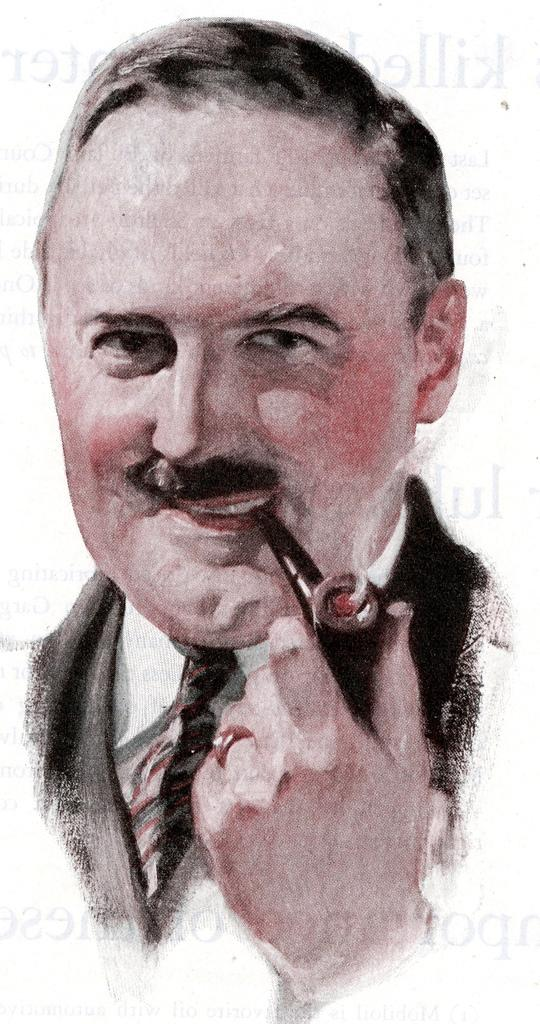What is the subject of the painting in the image? The image is a painting of a person. What expression does the person have in the painting? The person is smiling in the painting. What is the person holding in their mouth in the painting? There is a cigar in the person's mouth in the painting. What type of clothing is the person wearing on their upper body in the painting? The person is wearing a tie, a shirt, and a coat in the painting. What type of soup is the person eating in the painting? There is no soup present in the painting; the person is holding a cigar in their mouth. 